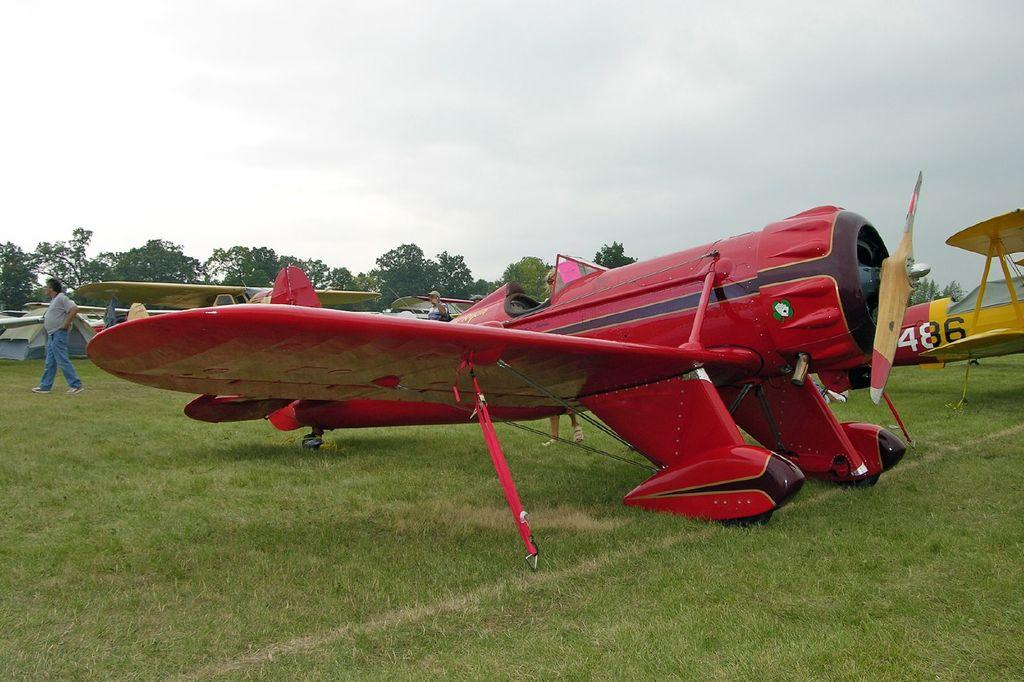<image>
Provide a brief description of the given image. A yellow airplane fuselage behind a red one bearing the number 486. 